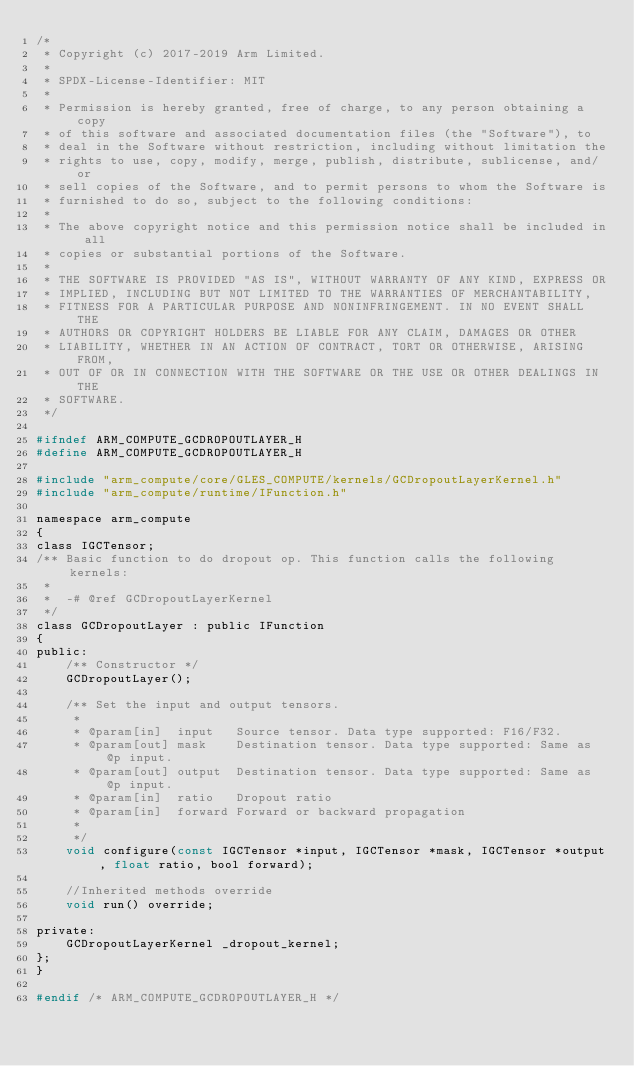Convert code to text. <code><loc_0><loc_0><loc_500><loc_500><_C_>/*
 * Copyright (c) 2017-2019 Arm Limited.
 *
 * SPDX-License-Identifier: MIT
 *
 * Permission is hereby granted, free of charge, to any person obtaining a copy
 * of this software and associated documentation files (the "Software"), to
 * deal in the Software without restriction, including without limitation the
 * rights to use, copy, modify, merge, publish, distribute, sublicense, and/or
 * sell copies of the Software, and to permit persons to whom the Software is
 * furnished to do so, subject to the following conditions:
 *
 * The above copyright notice and this permission notice shall be included in all
 * copies or substantial portions of the Software.
 *
 * THE SOFTWARE IS PROVIDED "AS IS", WITHOUT WARRANTY OF ANY KIND, EXPRESS OR
 * IMPLIED, INCLUDING BUT NOT LIMITED TO THE WARRANTIES OF MERCHANTABILITY,
 * FITNESS FOR A PARTICULAR PURPOSE AND NONINFRINGEMENT. IN NO EVENT SHALL THE
 * AUTHORS OR COPYRIGHT HOLDERS BE LIABLE FOR ANY CLAIM, DAMAGES OR OTHER
 * LIABILITY, WHETHER IN AN ACTION OF CONTRACT, TORT OR OTHERWISE, ARISING FROM,
 * OUT OF OR IN CONNECTION WITH THE SOFTWARE OR THE USE OR OTHER DEALINGS IN THE
 * SOFTWARE.
 */

#ifndef ARM_COMPUTE_GCDROPOUTLAYER_H
#define ARM_COMPUTE_GCDROPOUTLAYER_H

#include "arm_compute/core/GLES_COMPUTE/kernels/GCDropoutLayerKernel.h"
#include "arm_compute/runtime/IFunction.h"

namespace arm_compute
{
class IGCTensor;
/** Basic function to do dropout op. This function calls the following kernels:
 *
 *  -# @ref GCDropoutLayerKernel
 */
class GCDropoutLayer : public IFunction
{
public:
    /** Constructor */
    GCDropoutLayer();

    /** Set the input and output tensors.
     *
     * @param[in]  input   Source tensor. Data type supported: F16/F32.
     * @param[out] mask    Destination tensor. Data type supported: Same as @p input.
     * @param[out] output  Destination tensor. Data type supported: Same as @p input.
     * @param[in]  ratio   Dropout ratio
     * @param[in]  forward Forward or backward propagation
     *
     */
    void configure(const IGCTensor *input, IGCTensor *mask, IGCTensor *output, float ratio, bool forward);

    //Inherited methods override
    void run() override;

private:
    GCDropoutLayerKernel _dropout_kernel;
};
}

#endif /* ARM_COMPUTE_GCDROPOUTLAYER_H */
</code> 